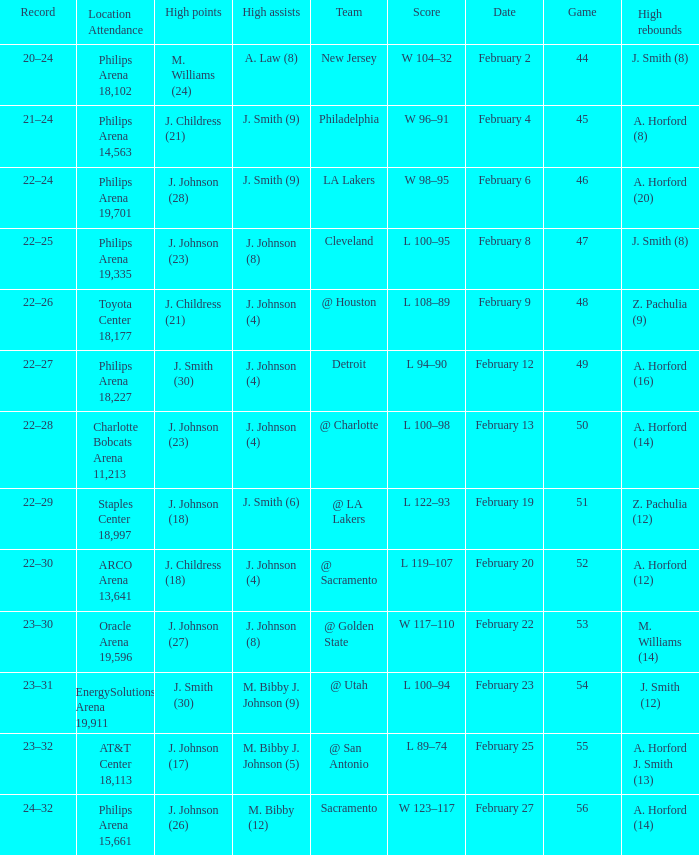What is the team located at philips arena 18,227? Detroit. 